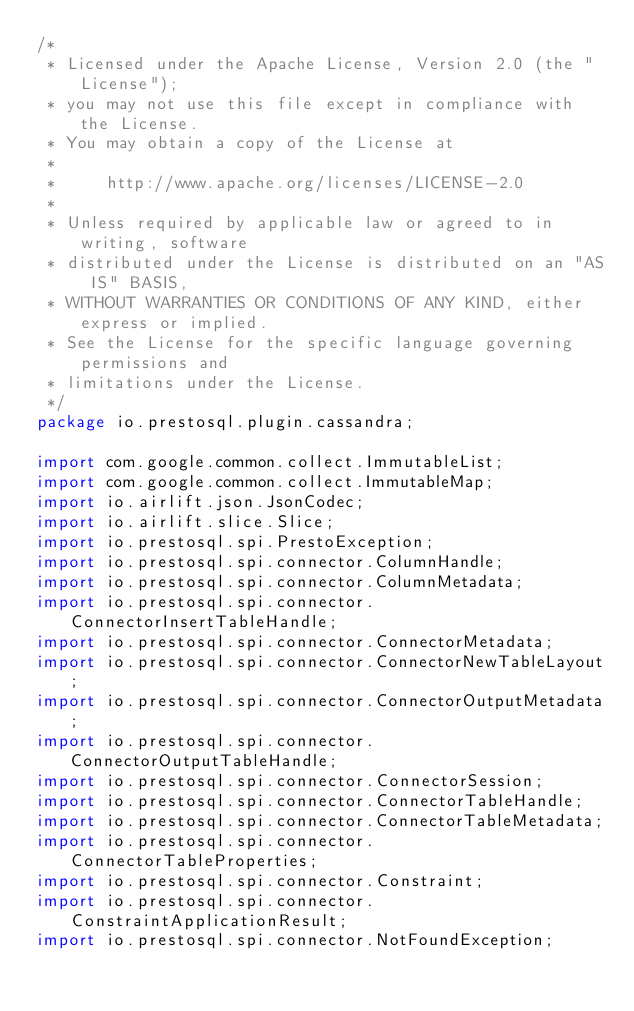<code> <loc_0><loc_0><loc_500><loc_500><_Java_>/*
 * Licensed under the Apache License, Version 2.0 (the "License");
 * you may not use this file except in compliance with the License.
 * You may obtain a copy of the License at
 *
 *     http://www.apache.org/licenses/LICENSE-2.0
 *
 * Unless required by applicable law or agreed to in writing, software
 * distributed under the License is distributed on an "AS IS" BASIS,
 * WITHOUT WARRANTIES OR CONDITIONS OF ANY KIND, either express or implied.
 * See the License for the specific language governing permissions and
 * limitations under the License.
 */
package io.prestosql.plugin.cassandra;

import com.google.common.collect.ImmutableList;
import com.google.common.collect.ImmutableMap;
import io.airlift.json.JsonCodec;
import io.airlift.slice.Slice;
import io.prestosql.spi.PrestoException;
import io.prestosql.spi.connector.ColumnHandle;
import io.prestosql.spi.connector.ColumnMetadata;
import io.prestosql.spi.connector.ConnectorInsertTableHandle;
import io.prestosql.spi.connector.ConnectorMetadata;
import io.prestosql.spi.connector.ConnectorNewTableLayout;
import io.prestosql.spi.connector.ConnectorOutputMetadata;
import io.prestosql.spi.connector.ConnectorOutputTableHandle;
import io.prestosql.spi.connector.ConnectorSession;
import io.prestosql.spi.connector.ConnectorTableHandle;
import io.prestosql.spi.connector.ConnectorTableMetadata;
import io.prestosql.spi.connector.ConnectorTableProperties;
import io.prestosql.spi.connector.Constraint;
import io.prestosql.spi.connector.ConstraintApplicationResult;
import io.prestosql.spi.connector.NotFoundException;</code> 